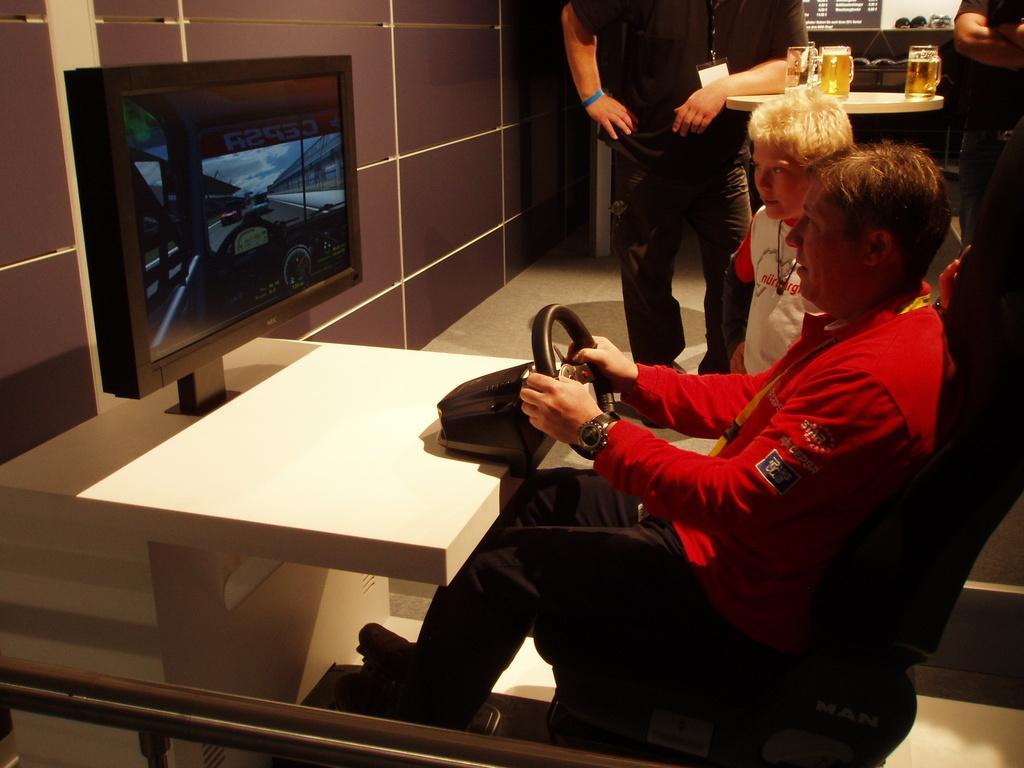Please provide a concise description of this image. In this image I can see a person sitting and holding a steering. The person is wearing red shirt, black color pant, in front I can see a screen. Background I can see few persons, few glasses on the table and the wall is in brown color. 